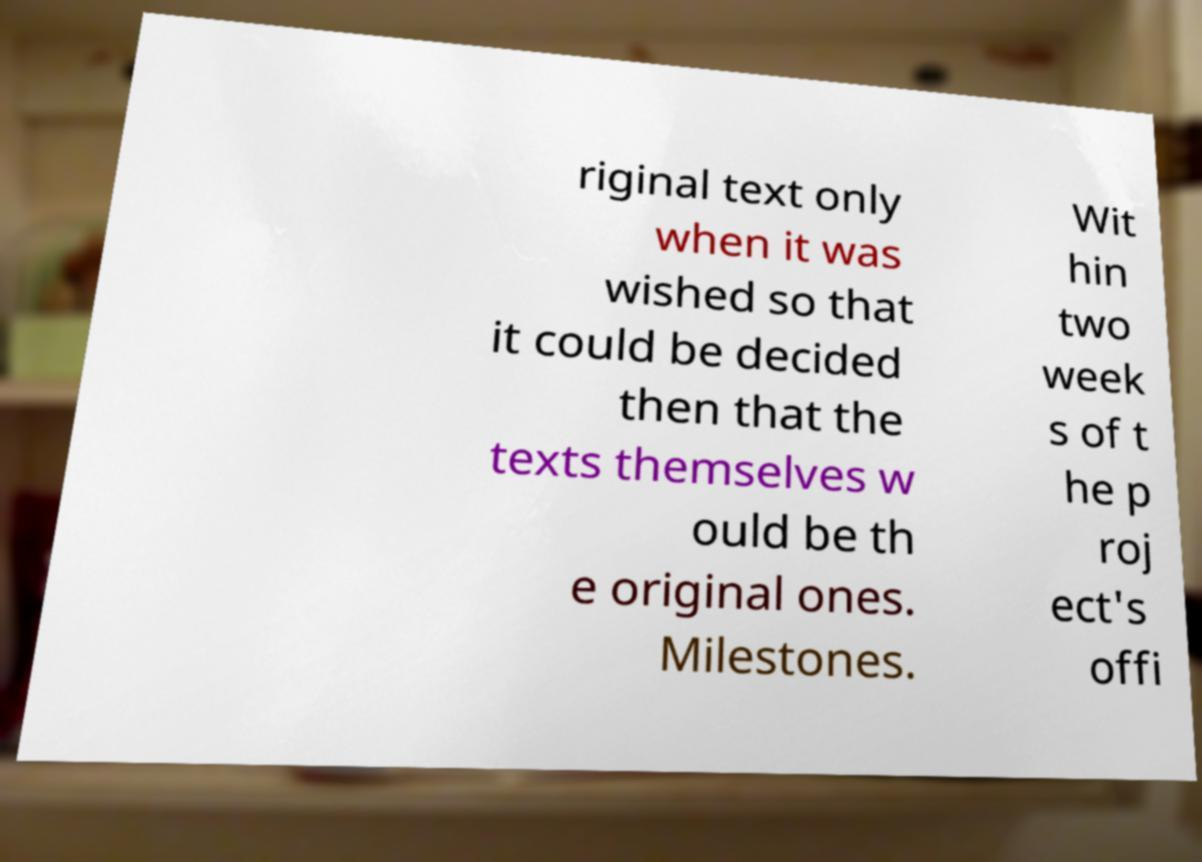There's text embedded in this image that I need extracted. Can you transcribe it verbatim? riginal text only when it was wished so that it could be decided then that the texts themselves w ould be th e original ones. Milestones. Wit hin two week s of t he p roj ect's offi 